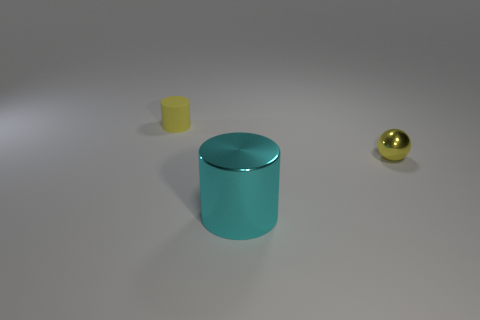Is there any other thing that has the same material as the small yellow cylinder?
Make the answer very short. No. The thing that is both behind the large shiny thing and in front of the matte cylinder is what color?
Ensure brevity in your answer.  Yellow. There is a cylinder that is behind the tiny sphere; is it the same size as the yellow thing that is right of the small rubber cylinder?
Your answer should be compact. Yes. What number of other metallic objects have the same color as the tiny shiny thing?
Provide a short and direct response. 0. What number of large objects are either metal balls or cyan metal objects?
Give a very brief answer. 1. Does the tiny yellow object that is in front of the yellow matte thing have the same material as the large cyan cylinder?
Provide a succinct answer. Yes. What is the color of the cylinder to the left of the metallic cylinder?
Provide a short and direct response. Yellow. Are there any rubber cylinders that have the same size as the sphere?
Your answer should be compact. Yes. There is another thing that is the same size as the yellow metallic object; what material is it?
Your response must be concise. Rubber. Is the size of the metal sphere the same as the yellow thing that is to the left of the tiny yellow ball?
Your answer should be very brief. Yes. 